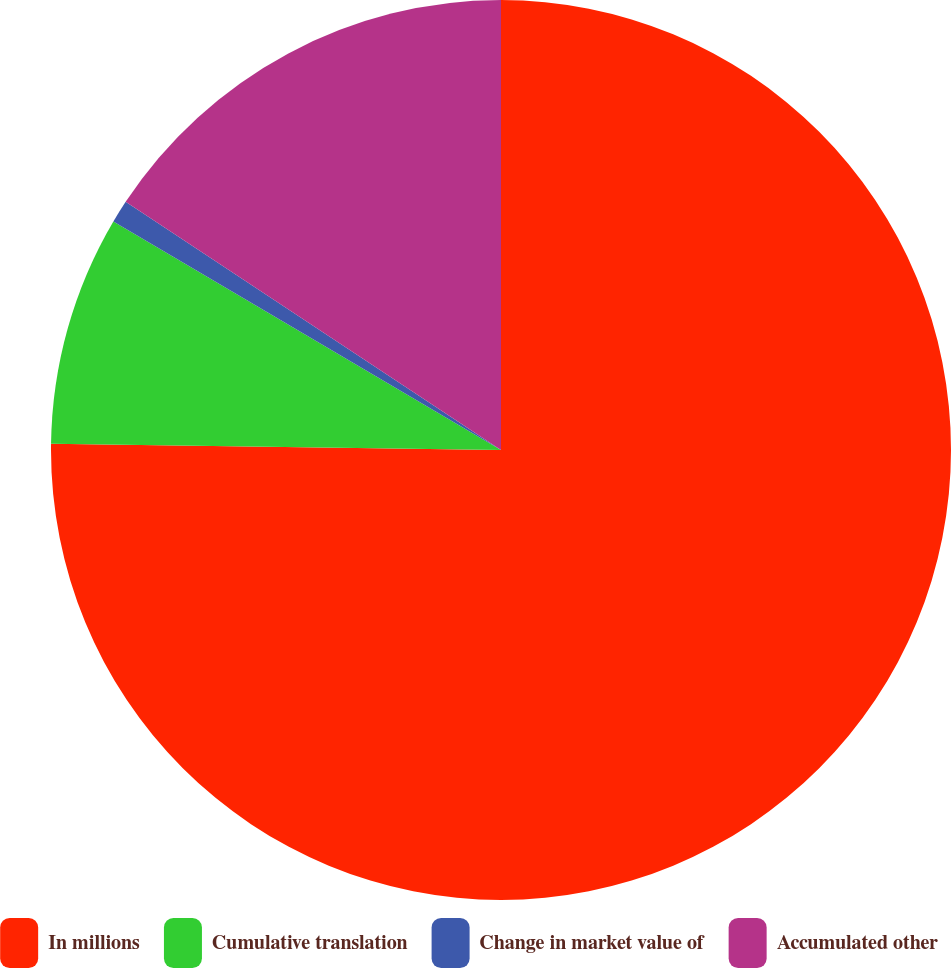<chart> <loc_0><loc_0><loc_500><loc_500><pie_chart><fcel>In millions<fcel>Cumulative translation<fcel>Change in market value of<fcel>Accumulated other<nl><fcel>75.22%<fcel>8.26%<fcel>0.82%<fcel>15.7%<nl></chart> 